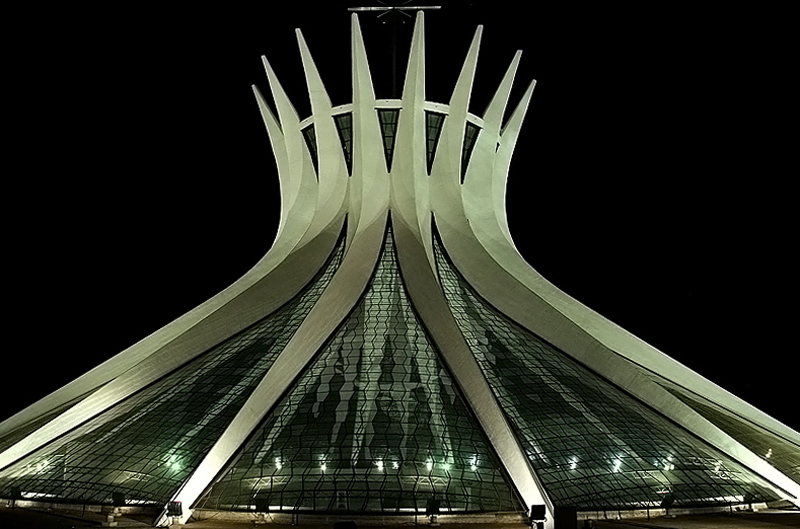What materials appear to have been used in the construction of this building, based on what you can see? From the image, it looks like glass is a primary material used in the façade, creating a translucent effect. Additionally, the supports and the sweeping elements of the structure suggest the use of reinforced concrete or steel, providing the necessary strength while allowing for the graceful, slim curves seen in the design. 